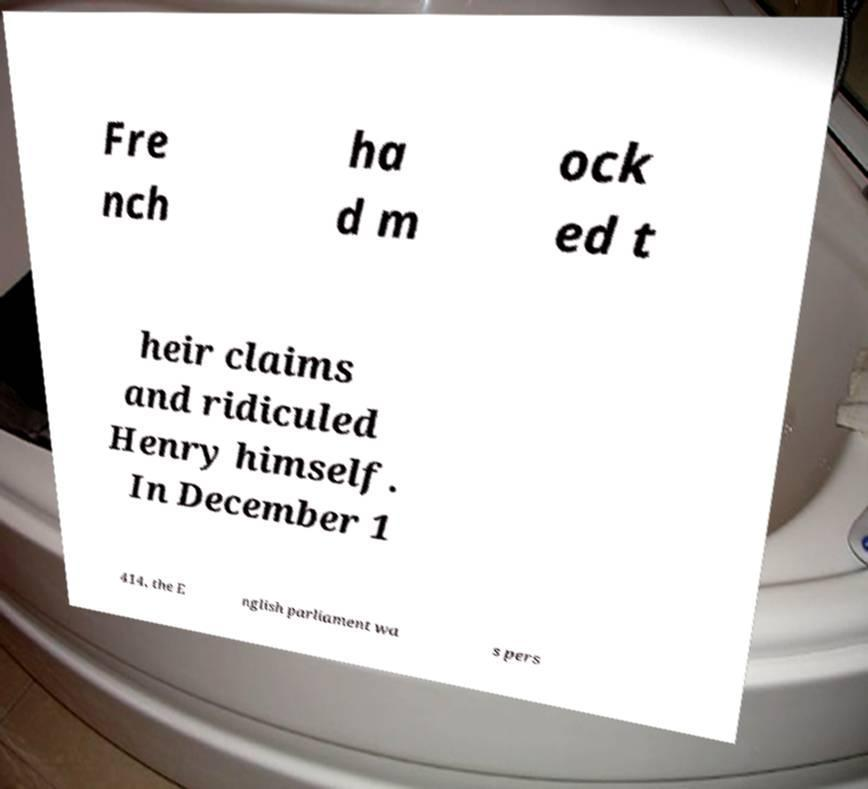There's text embedded in this image that I need extracted. Can you transcribe it verbatim? Fre nch ha d m ock ed t heir claims and ridiculed Henry himself. In December 1 414, the E nglish parliament wa s pers 